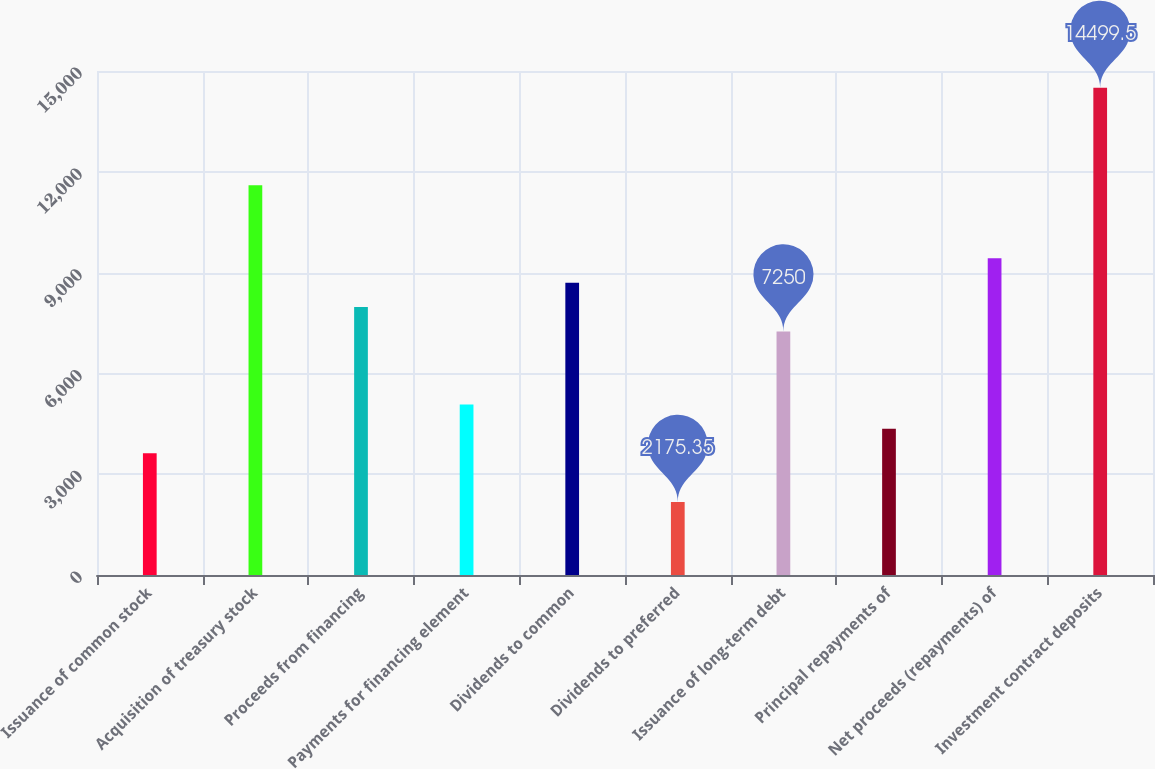Convert chart to OTSL. <chart><loc_0><loc_0><loc_500><loc_500><bar_chart><fcel>Issuance of common stock<fcel>Acquisition of treasury stock<fcel>Proceeds from financing<fcel>Payments for financing element<fcel>Dividends to common<fcel>Dividends to preferred<fcel>Issuance of long-term debt<fcel>Principal repayments of<fcel>Net proceeds (repayments) of<fcel>Investment contract deposits<nl><fcel>3625.25<fcel>11599.7<fcel>7974.95<fcel>5075.15<fcel>8699.9<fcel>2175.35<fcel>7250<fcel>4350.2<fcel>9424.85<fcel>14499.5<nl></chart> 